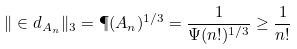<formula> <loc_0><loc_0><loc_500><loc_500>\| \in d _ { A _ { n } } \| _ { 3 } = \P ( A _ { n } ) ^ { 1 / 3 } = \frac { 1 } { \Psi ( n ! ) ^ { 1 / 3 } } \geq \frac { 1 } { n ! }</formula> 